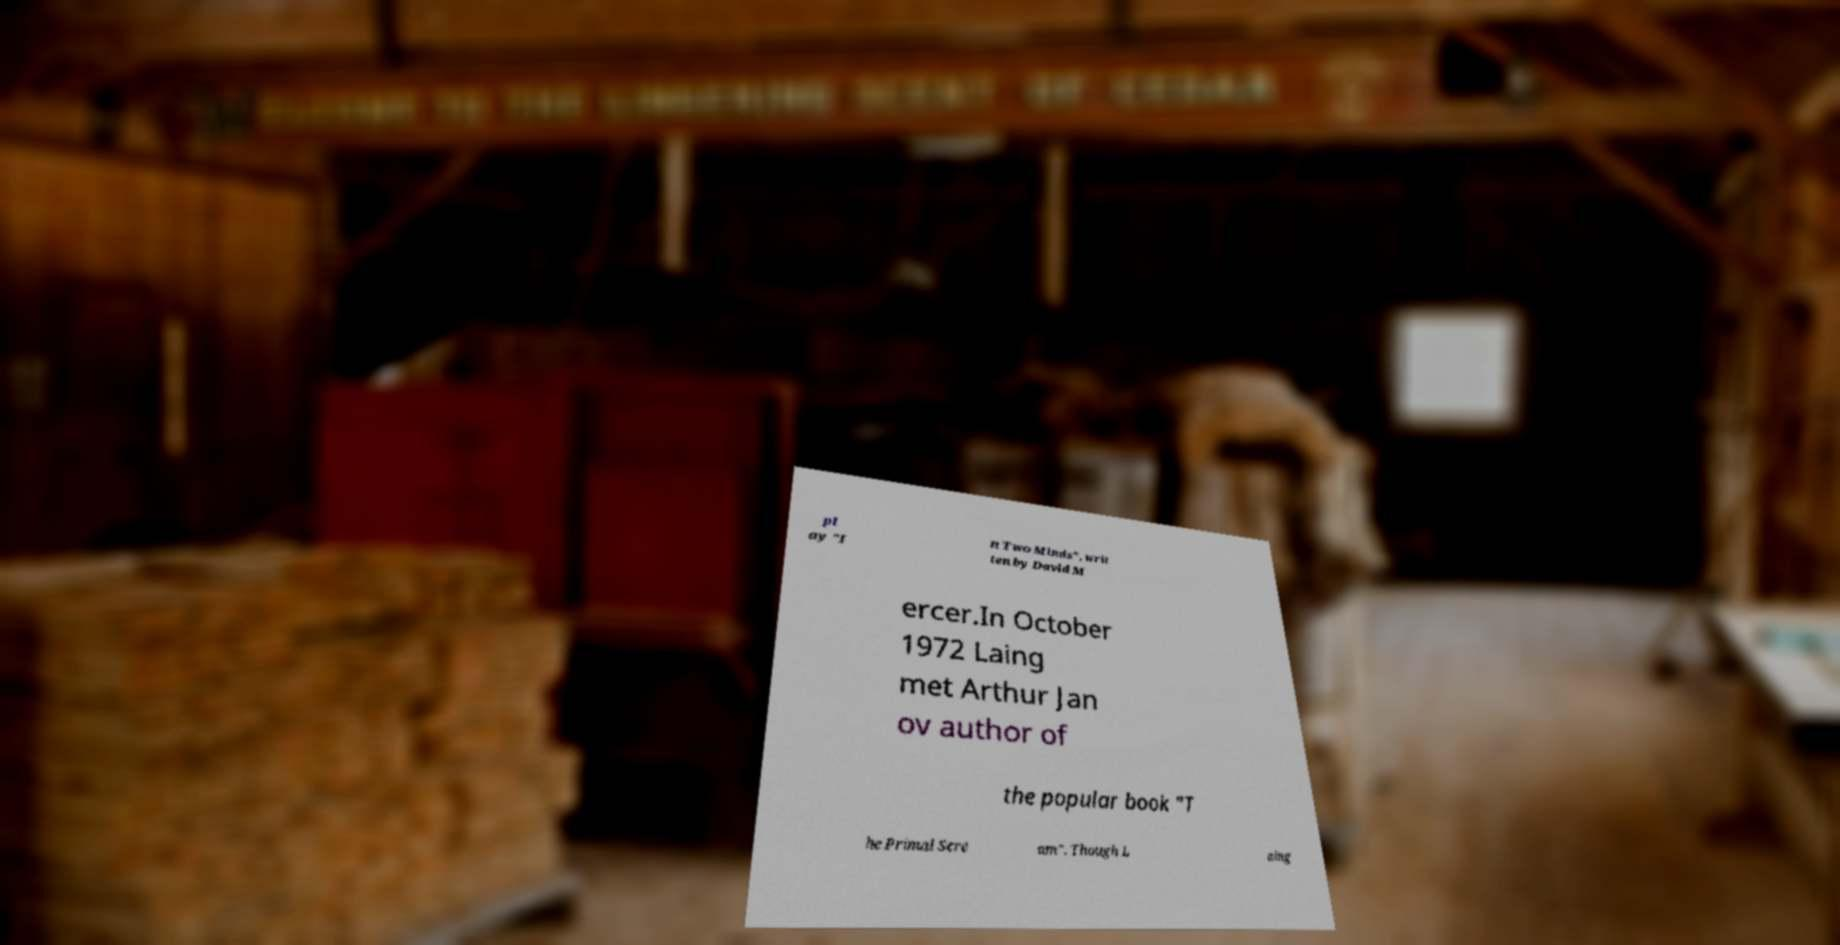There's text embedded in this image that I need extracted. Can you transcribe it verbatim? pl ay "I n Two Minds", writ ten by David M ercer.In October 1972 Laing met Arthur Jan ov author of the popular book "T he Primal Scre am". Though L aing 